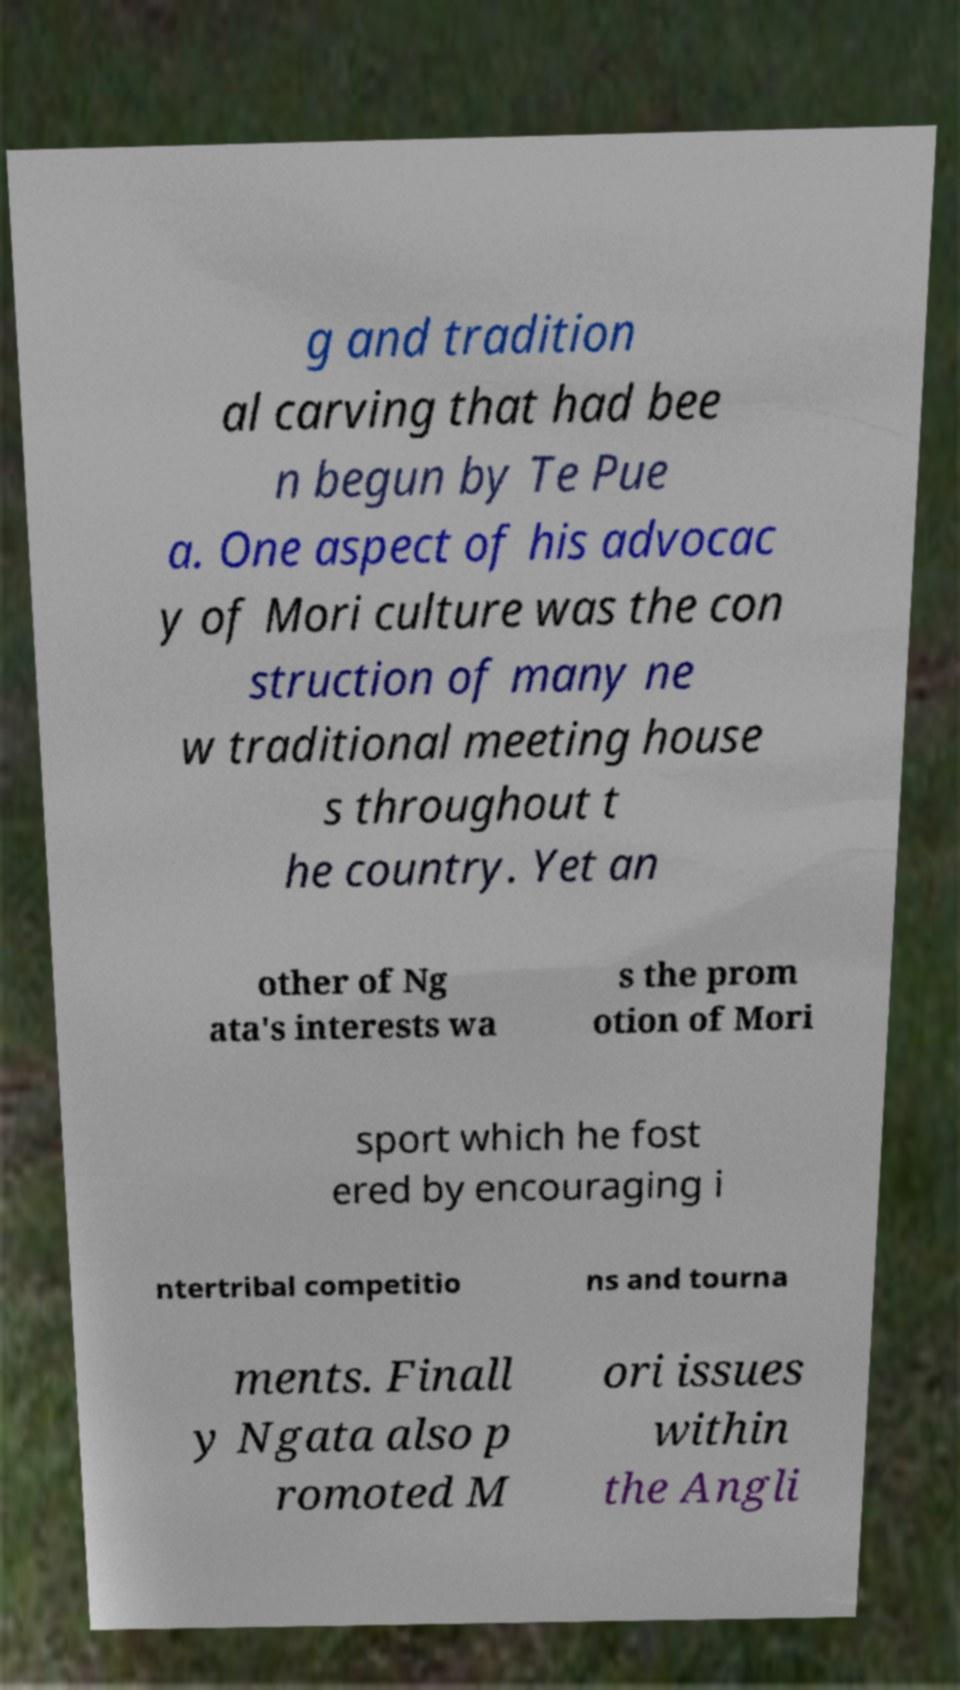What messages or text are displayed in this image? I need them in a readable, typed format. g and tradition al carving that had bee n begun by Te Pue a. One aspect of his advocac y of Mori culture was the con struction of many ne w traditional meeting house s throughout t he country. Yet an other of Ng ata's interests wa s the prom otion of Mori sport which he fost ered by encouraging i ntertribal competitio ns and tourna ments. Finall y Ngata also p romoted M ori issues within the Angli 